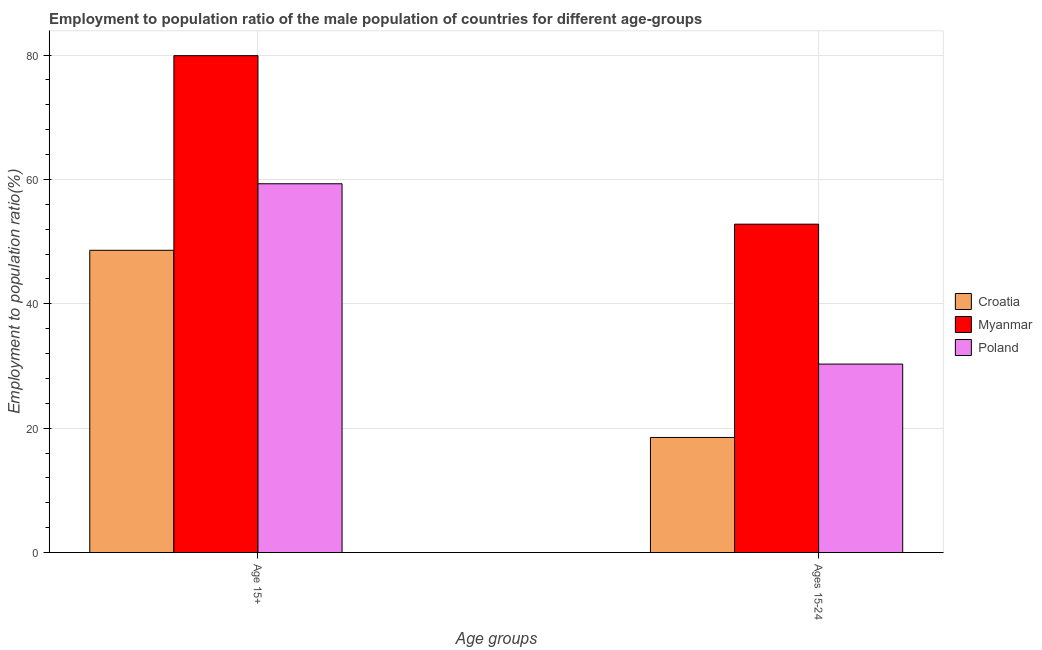How many different coloured bars are there?
Provide a succinct answer. 3. Are the number of bars on each tick of the X-axis equal?
Make the answer very short. Yes. How many bars are there on the 1st tick from the right?
Provide a short and direct response. 3. What is the label of the 2nd group of bars from the left?
Your response must be concise. Ages 15-24. What is the employment to population ratio(age 15+) in Poland?
Your response must be concise. 59.3. Across all countries, what is the maximum employment to population ratio(age 15-24)?
Keep it short and to the point. 52.8. In which country was the employment to population ratio(age 15-24) maximum?
Provide a short and direct response. Myanmar. In which country was the employment to population ratio(age 15+) minimum?
Offer a terse response. Croatia. What is the total employment to population ratio(age 15-24) in the graph?
Keep it short and to the point. 101.6. What is the difference between the employment to population ratio(age 15+) in Myanmar and that in Poland?
Offer a very short reply. 20.6. What is the difference between the employment to population ratio(age 15-24) in Myanmar and the employment to population ratio(age 15+) in Poland?
Keep it short and to the point. -6.5. What is the average employment to population ratio(age 15-24) per country?
Provide a short and direct response. 33.87. What is the difference between the employment to population ratio(age 15-24) and employment to population ratio(age 15+) in Poland?
Provide a short and direct response. -29. In how many countries, is the employment to population ratio(age 15-24) greater than 12 %?
Your answer should be very brief. 3. What is the ratio of the employment to population ratio(age 15+) in Croatia to that in Poland?
Keep it short and to the point. 0.82. What does the 2nd bar from the left in Age 15+ represents?
Provide a short and direct response. Myanmar. What does the 3rd bar from the right in Age 15+ represents?
Ensure brevity in your answer.  Croatia. Are all the bars in the graph horizontal?
Give a very brief answer. No. What is the difference between two consecutive major ticks on the Y-axis?
Ensure brevity in your answer.  20. How are the legend labels stacked?
Ensure brevity in your answer.  Vertical. What is the title of the graph?
Give a very brief answer. Employment to population ratio of the male population of countries for different age-groups. What is the label or title of the X-axis?
Your answer should be compact. Age groups. What is the label or title of the Y-axis?
Offer a terse response. Employment to population ratio(%). What is the Employment to population ratio(%) in Croatia in Age 15+?
Make the answer very short. 48.6. What is the Employment to population ratio(%) of Myanmar in Age 15+?
Offer a very short reply. 79.9. What is the Employment to population ratio(%) in Poland in Age 15+?
Provide a succinct answer. 59.3. What is the Employment to population ratio(%) in Croatia in Ages 15-24?
Your answer should be very brief. 18.5. What is the Employment to population ratio(%) of Myanmar in Ages 15-24?
Offer a terse response. 52.8. What is the Employment to population ratio(%) in Poland in Ages 15-24?
Make the answer very short. 30.3. Across all Age groups, what is the maximum Employment to population ratio(%) of Croatia?
Ensure brevity in your answer.  48.6. Across all Age groups, what is the maximum Employment to population ratio(%) of Myanmar?
Offer a very short reply. 79.9. Across all Age groups, what is the maximum Employment to population ratio(%) in Poland?
Your answer should be very brief. 59.3. Across all Age groups, what is the minimum Employment to population ratio(%) of Croatia?
Your answer should be very brief. 18.5. Across all Age groups, what is the minimum Employment to population ratio(%) of Myanmar?
Offer a terse response. 52.8. Across all Age groups, what is the minimum Employment to population ratio(%) of Poland?
Provide a short and direct response. 30.3. What is the total Employment to population ratio(%) of Croatia in the graph?
Your answer should be very brief. 67.1. What is the total Employment to population ratio(%) of Myanmar in the graph?
Your answer should be compact. 132.7. What is the total Employment to population ratio(%) in Poland in the graph?
Offer a terse response. 89.6. What is the difference between the Employment to population ratio(%) of Croatia in Age 15+ and that in Ages 15-24?
Give a very brief answer. 30.1. What is the difference between the Employment to population ratio(%) of Myanmar in Age 15+ and that in Ages 15-24?
Your answer should be very brief. 27.1. What is the difference between the Employment to population ratio(%) of Croatia in Age 15+ and the Employment to population ratio(%) of Myanmar in Ages 15-24?
Provide a short and direct response. -4.2. What is the difference between the Employment to population ratio(%) in Myanmar in Age 15+ and the Employment to population ratio(%) in Poland in Ages 15-24?
Keep it short and to the point. 49.6. What is the average Employment to population ratio(%) in Croatia per Age groups?
Offer a terse response. 33.55. What is the average Employment to population ratio(%) of Myanmar per Age groups?
Provide a succinct answer. 66.35. What is the average Employment to population ratio(%) of Poland per Age groups?
Make the answer very short. 44.8. What is the difference between the Employment to population ratio(%) in Croatia and Employment to population ratio(%) in Myanmar in Age 15+?
Keep it short and to the point. -31.3. What is the difference between the Employment to population ratio(%) in Croatia and Employment to population ratio(%) in Poland in Age 15+?
Your response must be concise. -10.7. What is the difference between the Employment to population ratio(%) of Myanmar and Employment to population ratio(%) of Poland in Age 15+?
Your answer should be very brief. 20.6. What is the difference between the Employment to population ratio(%) in Croatia and Employment to population ratio(%) in Myanmar in Ages 15-24?
Your answer should be compact. -34.3. What is the difference between the Employment to population ratio(%) of Myanmar and Employment to population ratio(%) of Poland in Ages 15-24?
Your answer should be very brief. 22.5. What is the ratio of the Employment to population ratio(%) of Croatia in Age 15+ to that in Ages 15-24?
Your answer should be very brief. 2.63. What is the ratio of the Employment to population ratio(%) of Myanmar in Age 15+ to that in Ages 15-24?
Provide a short and direct response. 1.51. What is the ratio of the Employment to population ratio(%) in Poland in Age 15+ to that in Ages 15-24?
Make the answer very short. 1.96. What is the difference between the highest and the second highest Employment to population ratio(%) in Croatia?
Ensure brevity in your answer.  30.1. What is the difference between the highest and the second highest Employment to population ratio(%) of Myanmar?
Offer a very short reply. 27.1. What is the difference between the highest and the lowest Employment to population ratio(%) of Croatia?
Your response must be concise. 30.1. What is the difference between the highest and the lowest Employment to population ratio(%) in Myanmar?
Offer a terse response. 27.1. 